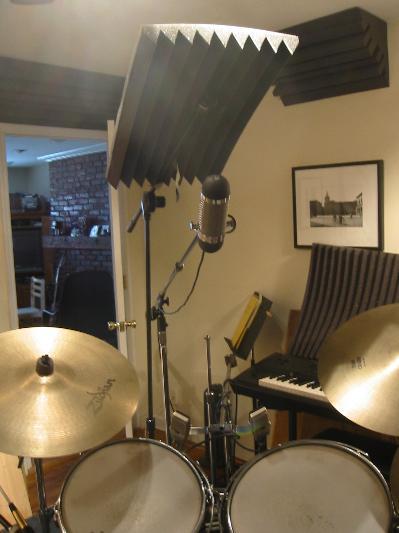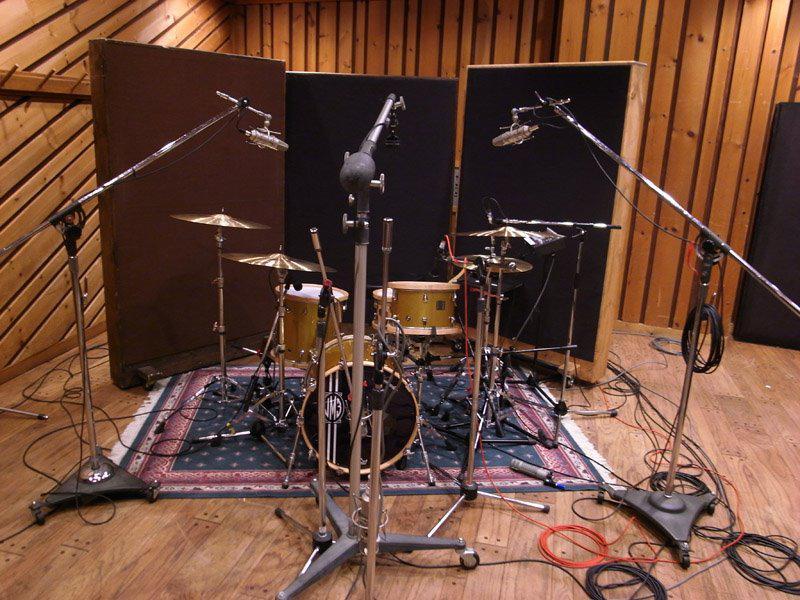The first image is the image on the left, the second image is the image on the right. For the images displayed, is the sentence "There is a kick drum with white skin." factually correct? Answer yes or no. No. The first image is the image on the left, the second image is the image on the right. Considering the images on both sides, is "The drumset sits on a rectangular rug in one of the images." valid? Answer yes or no. Yes. 